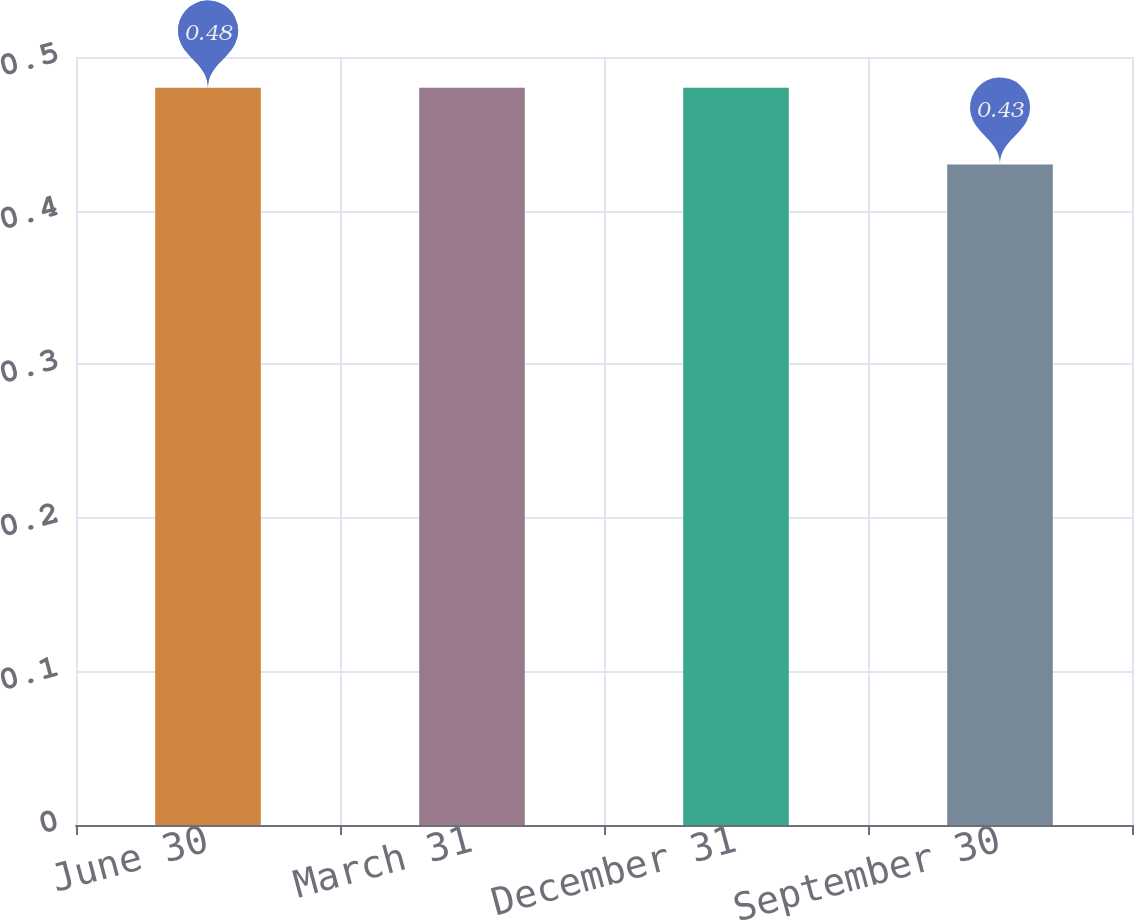<chart> <loc_0><loc_0><loc_500><loc_500><bar_chart><fcel>June 30<fcel>March 31<fcel>December 31<fcel>September 30<nl><fcel>0.48<fcel>0.48<fcel>0.48<fcel>0.43<nl></chart> 